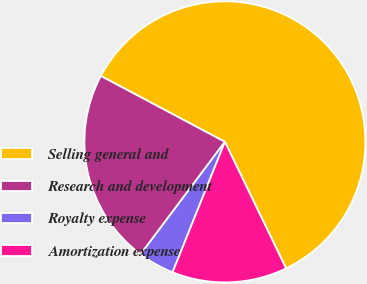Convert chart. <chart><loc_0><loc_0><loc_500><loc_500><pie_chart><fcel>Selling general and<fcel>Research and development<fcel>Royalty expense<fcel>Amortization expense<nl><fcel>60.07%<fcel>22.53%<fcel>4.17%<fcel>13.24%<nl></chart> 